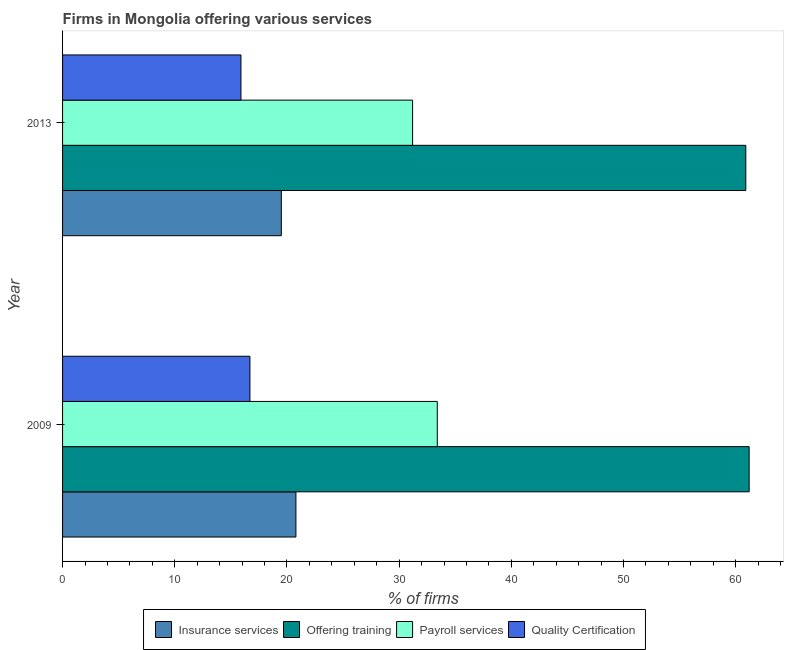Are the number of bars on each tick of the Y-axis equal?
Keep it short and to the point. Yes. How many bars are there on the 1st tick from the bottom?
Provide a short and direct response. 4. In how many cases, is the number of bars for a given year not equal to the number of legend labels?
Offer a terse response. 0. What is the percentage of firms offering insurance services in 2009?
Give a very brief answer. 20.8. Across all years, what is the maximum percentage of firms offering insurance services?
Ensure brevity in your answer.  20.8. Across all years, what is the minimum percentage of firms offering training?
Offer a very short reply. 60.9. What is the total percentage of firms offering payroll services in the graph?
Your answer should be compact. 64.6. What is the difference between the percentage of firms offering quality certification in 2009 and that in 2013?
Keep it short and to the point. 0.8. What is the difference between the percentage of firms offering training in 2013 and the percentage of firms offering quality certification in 2009?
Your response must be concise. 44.2. What is the average percentage of firms offering insurance services per year?
Give a very brief answer. 20.15. In how many years, is the percentage of firms offering insurance services greater than 54 %?
Offer a terse response. 0. What is the ratio of the percentage of firms offering quality certification in 2009 to that in 2013?
Ensure brevity in your answer.  1.05. Is the difference between the percentage of firms offering payroll services in 2009 and 2013 greater than the difference between the percentage of firms offering quality certification in 2009 and 2013?
Give a very brief answer. Yes. In how many years, is the percentage of firms offering payroll services greater than the average percentage of firms offering payroll services taken over all years?
Your answer should be compact. 1. What does the 3rd bar from the top in 2009 represents?
Keep it short and to the point. Offering training. What does the 3rd bar from the bottom in 2013 represents?
Give a very brief answer. Payroll services. How many bars are there?
Provide a succinct answer. 8. Are all the bars in the graph horizontal?
Make the answer very short. Yes. How many years are there in the graph?
Your answer should be compact. 2. What is the difference between two consecutive major ticks on the X-axis?
Give a very brief answer. 10. Does the graph contain any zero values?
Give a very brief answer. No. Does the graph contain grids?
Your response must be concise. No. How many legend labels are there?
Make the answer very short. 4. How are the legend labels stacked?
Offer a terse response. Horizontal. What is the title of the graph?
Ensure brevity in your answer.  Firms in Mongolia offering various services . What is the label or title of the X-axis?
Your answer should be compact. % of firms. What is the label or title of the Y-axis?
Provide a succinct answer. Year. What is the % of firms in Insurance services in 2009?
Your response must be concise. 20.8. What is the % of firms of Offering training in 2009?
Your response must be concise. 61.2. What is the % of firms of Payroll services in 2009?
Ensure brevity in your answer.  33.4. What is the % of firms of Insurance services in 2013?
Keep it short and to the point. 19.5. What is the % of firms in Offering training in 2013?
Your answer should be very brief. 60.9. What is the % of firms in Payroll services in 2013?
Your answer should be compact. 31.2. What is the % of firms of Quality Certification in 2013?
Your answer should be very brief. 15.9. Across all years, what is the maximum % of firms of Insurance services?
Make the answer very short. 20.8. Across all years, what is the maximum % of firms of Offering training?
Offer a terse response. 61.2. Across all years, what is the maximum % of firms of Payroll services?
Offer a terse response. 33.4. Across all years, what is the minimum % of firms of Offering training?
Make the answer very short. 60.9. Across all years, what is the minimum % of firms of Payroll services?
Ensure brevity in your answer.  31.2. What is the total % of firms in Insurance services in the graph?
Provide a short and direct response. 40.3. What is the total % of firms in Offering training in the graph?
Your answer should be very brief. 122.1. What is the total % of firms of Payroll services in the graph?
Ensure brevity in your answer.  64.6. What is the total % of firms of Quality Certification in the graph?
Offer a very short reply. 32.6. What is the difference between the % of firms of Insurance services in 2009 and that in 2013?
Make the answer very short. 1.3. What is the difference between the % of firms in Offering training in 2009 and that in 2013?
Provide a short and direct response. 0.3. What is the difference between the % of firms of Quality Certification in 2009 and that in 2013?
Give a very brief answer. 0.8. What is the difference between the % of firms of Insurance services in 2009 and the % of firms of Offering training in 2013?
Your answer should be very brief. -40.1. What is the difference between the % of firms in Insurance services in 2009 and the % of firms in Payroll services in 2013?
Provide a short and direct response. -10.4. What is the difference between the % of firms in Offering training in 2009 and the % of firms in Payroll services in 2013?
Provide a short and direct response. 30. What is the difference between the % of firms of Offering training in 2009 and the % of firms of Quality Certification in 2013?
Make the answer very short. 45.3. What is the difference between the % of firms of Payroll services in 2009 and the % of firms of Quality Certification in 2013?
Provide a succinct answer. 17.5. What is the average % of firms in Insurance services per year?
Offer a very short reply. 20.15. What is the average % of firms of Offering training per year?
Provide a short and direct response. 61.05. What is the average % of firms in Payroll services per year?
Your answer should be very brief. 32.3. In the year 2009, what is the difference between the % of firms in Insurance services and % of firms in Offering training?
Make the answer very short. -40.4. In the year 2009, what is the difference between the % of firms in Offering training and % of firms in Payroll services?
Provide a short and direct response. 27.8. In the year 2009, what is the difference between the % of firms of Offering training and % of firms of Quality Certification?
Your response must be concise. 44.5. In the year 2013, what is the difference between the % of firms of Insurance services and % of firms of Offering training?
Provide a succinct answer. -41.4. In the year 2013, what is the difference between the % of firms of Insurance services and % of firms of Payroll services?
Keep it short and to the point. -11.7. In the year 2013, what is the difference between the % of firms of Insurance services and % of firms of Quality Certification?
Your answer should be compact. 3.6. In the year 2013, what is the difference between the % of firms of Offering training and % of firms of Payroll services?
Your answer should be very brief. 29.7. What is the ratio of the % of firms in Insurance services in 2009 to that in 2013?
Your answer should be compact. 1.07. What is the ratio of the % of firms of Offering training in 2009 to that in 2013?
Ensure brevity in your answer.  1. What is the ratio of the % of firms in Payroll services in 2009 to that in 2013?
Provide a short and direct response. 1.07. What is the ratio of the % of firms of Quality Certification in 2009 to that in 2013?
Provide a short and direct response. 1.05. What is the difference between the highest and the second highest % of firms in Offering training?
Provide a succinct answer. 0.3. What is the difference between the highest and the second highest % of firms of Payroll services?
Provide a succinct answer. 2.2. What is the difference between the highest and the lowest % of firms of Quality Certification?
Keep it short and to the point. 0.8. 